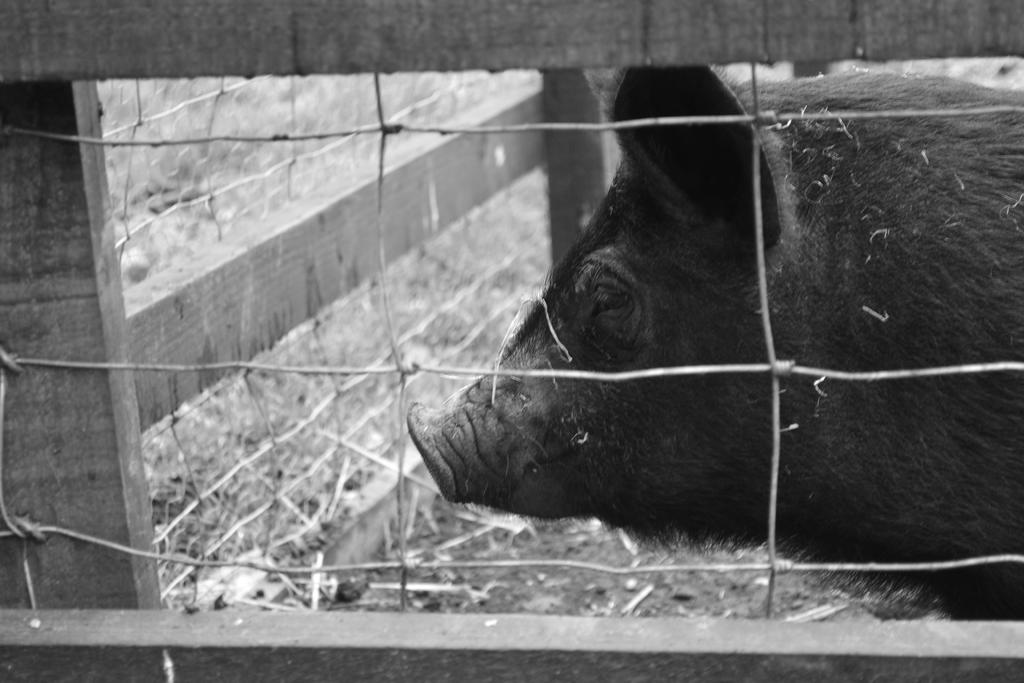What is present in the image that serves as a barrier? There is a fence in the image that serves as a barrier. What animal can be seen behind the fence? There is a pig behind the fence. How would you describe the color scheme of the image? The image is black and white. How many trees can be seen in the image? There are no trees present in the image. What type of drain is visible in the image? There is no drain present in the image. 